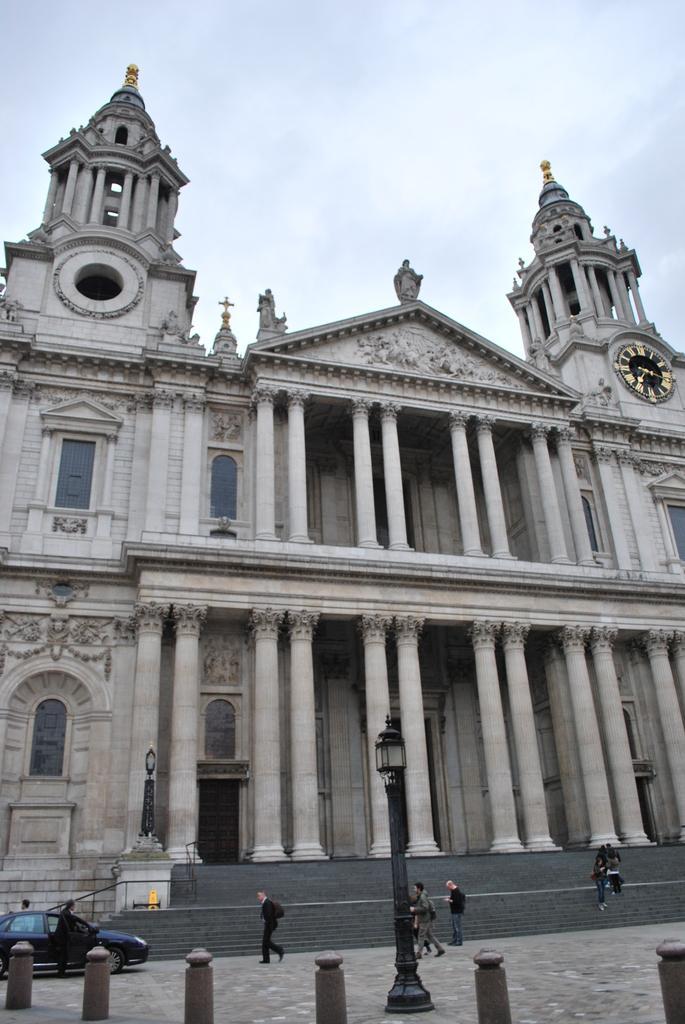Please provide a concise description of this image. In the image there are few persons walking on the road, There is a black car on the left side and behind there is a palace with clock in the middle of right side pillar and above its sky with clouds, there is a street lamp in the middle of the road. 